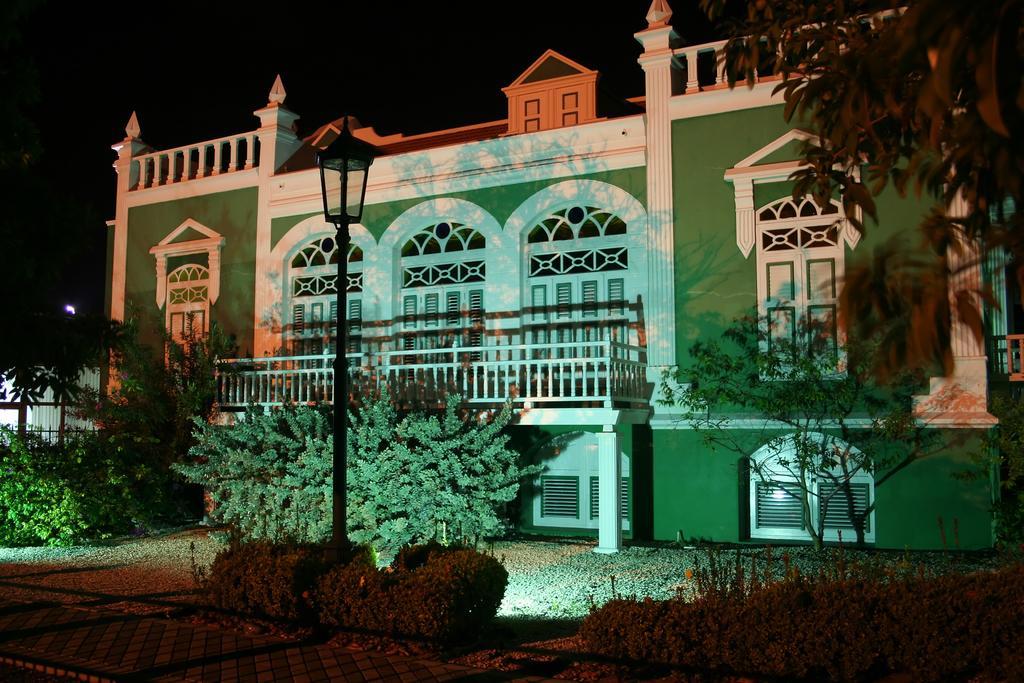How would you summarize this image in a sentence or two? In this image there is a pavement, beside that there are plants and a grassland and a light pole, in the background there is a house. 